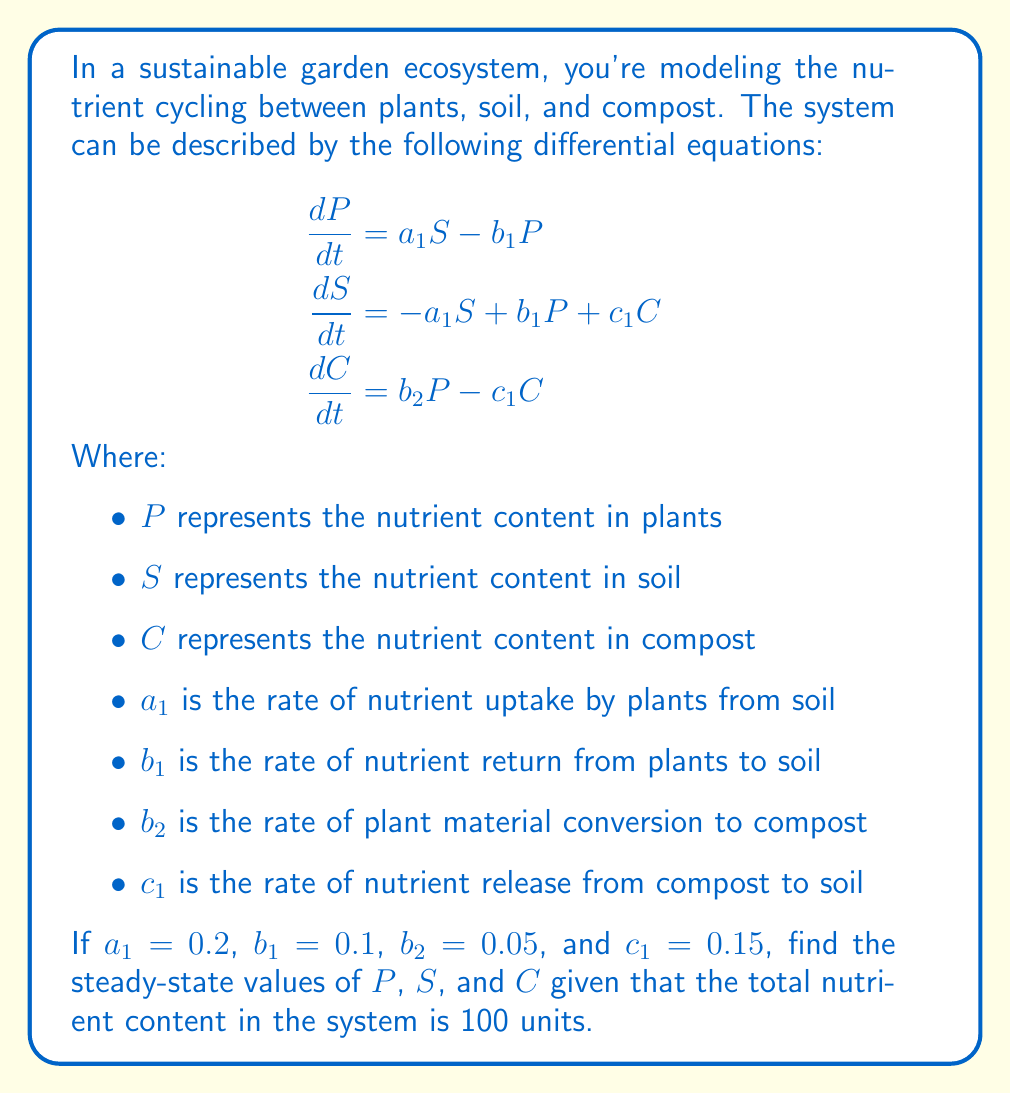Can you solve this math problem? To solve this problem, we need to follow these steps:

1) At steady state, the rate of change for each component is zero. So we set each differential equation to zero:

   $$\begin{aligned}
   0 &= a_1S - b_1P \\
   0 &= -a_1S + b_1P + c_1C \\
   0 &= b_2P - c_1C
   \end{aligned}$$

2) Substitute the given values:

   $$\begin{aligned}
   0 &= 0.2S - 0.1P \\
   0 &= -0.2S + 0.1P + 0.15C \\
   0 &= 0.05P - 0.15C
   \end{aligned}$$

3) From the third equation:
   
   $0.05P = 0.15C$
   $P = 3C$

4) Substitute this into the first equation:
   
   $0 = 0.2S - 0.1(3C)$
   $0 = 0.2S - 0.3C$
   $S = 1.5C$

5) Now we know that $P = 3C$ and $S = 1.5C$. Since the total nutrient content is 100 units:

   $P + S + C = 100$
   $3C + 1.5C + C = 100$
   $5.5C = 100$
   $C = 18.18$

6) Now we can calculate $P$ and $S$:
   
   $P = 3C = 3(18.18) = 54.54$
   $S = 1.5C = 1.5(18.18) = 27.27$

7) Rounding to two decimal places:
   
   $P = 54.54$
   $S = 27.27$
   $C = 18.18$
Answer: The steady-state values are: $P = 54.54$, $S = 27.27$, and $C = 18.18$ (rounded to two decimal places). 